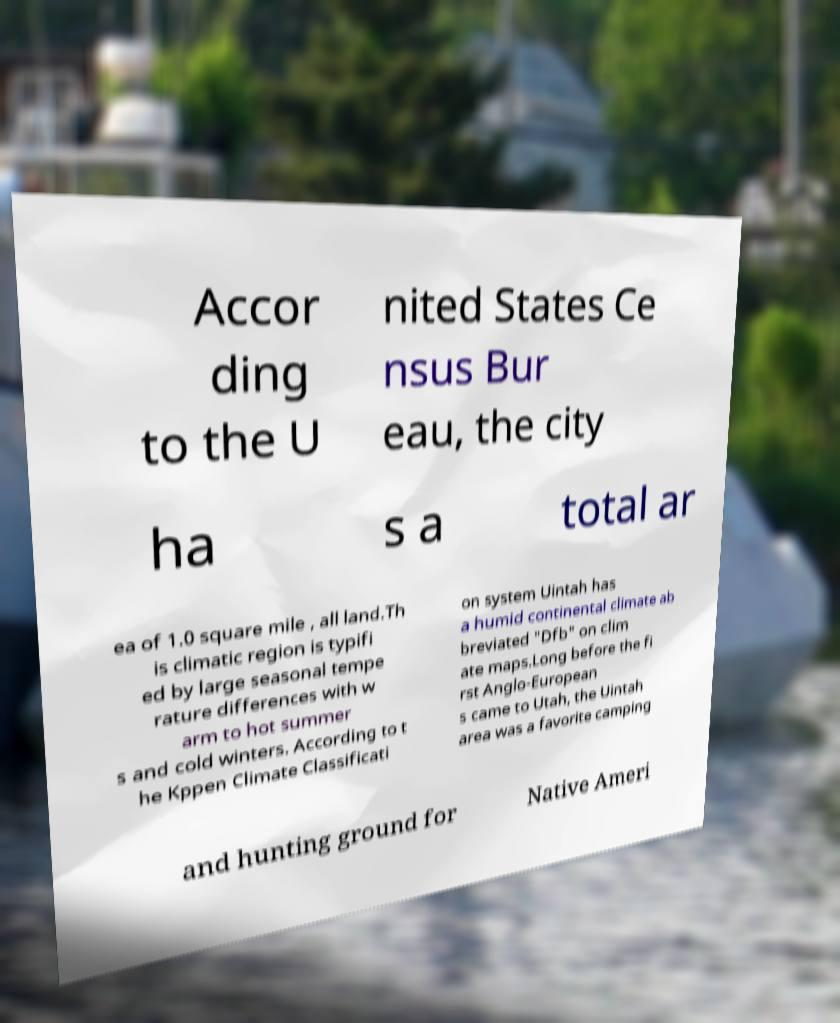There's text embedded in this image that I need extracted. Can you transcribe it verbatim? Accor ding to the U nited States Ce nsus Bur eau, the city ha s a total ar ea of 1.0 square mile , all land.Th is climatic region is typifi ed by large seasonal tempe rature differences with w arm to hot summer s and cold winters. According to t he Kppen Climate Classificati on system Uintah has a humid continental climate ab breviated "Dfb" on clim ate maps.Long before the fi rst Anglo-European s came to Utah, the Uintah area was a favorite camping and hunting ground for Native Ameri 